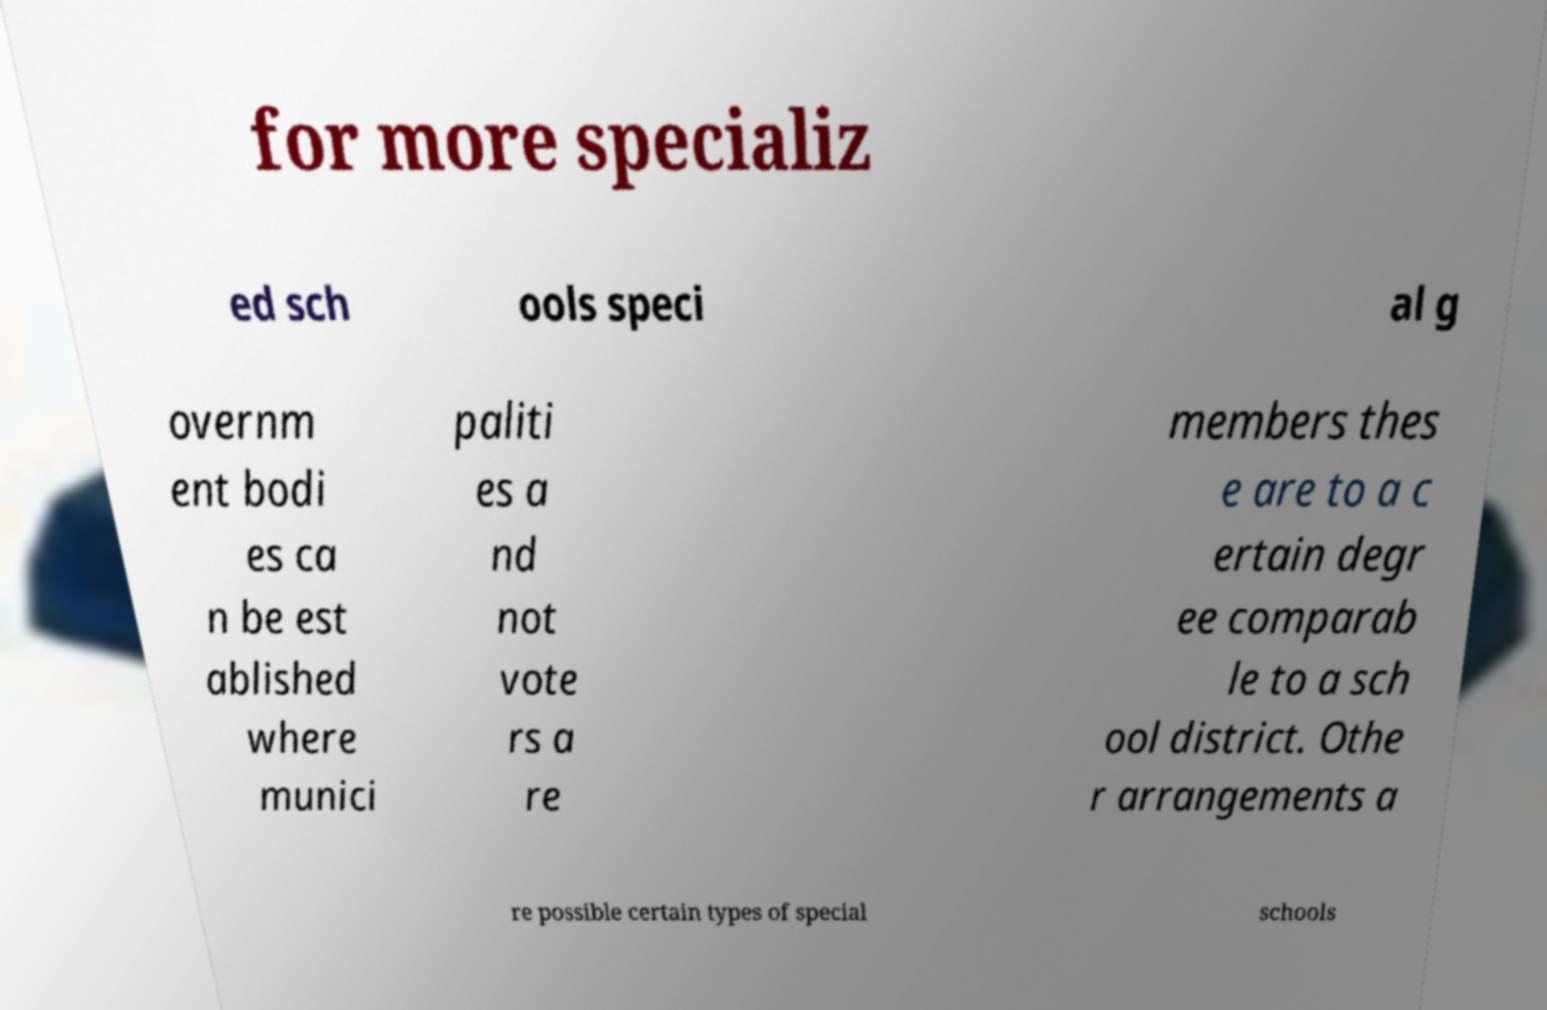There's text embedded in this image that I need extracted. Can you transcribe it verbatim? for more specializ ed sch ools speci al g overnm ent bodi es ca n be est ablished where munici paliti es a nd not vote rs a re members thes e are to a c ertain degr ee comparab le to a sch ool district. Othe r arrangements a re possible certain types of special schools 